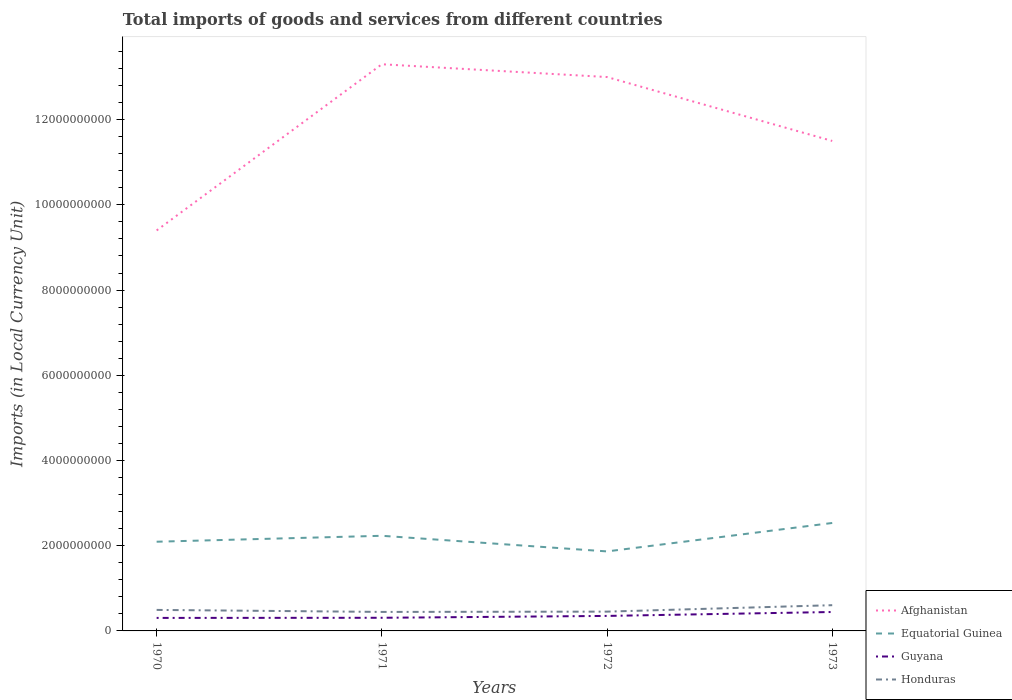How many different coloured lines are there?
Provide a succinct answer. 4. Does the line corresponding to Honduras intersect with the line corresponding to Afghanistan?
Give a very brief answer. No. Is the number of lines equal to the number of legend labels?
Provide a succinct answer. Yes. Across all years, what is the maximum Amount of goods and services imports in Honduras?
Provide a short and direct response. 4.46e+08. In which year was the Amount of goods and services imports in Afghanistan maximum?
Give a very brief answer. 1970. What is the total Amount of goods and services imports in Guyana in the graph?
Your answer should be very brief. -1.39e+08. What is the difference between the highest and the second highest Amount of goods and services imports in Afghanistan?
Provide a succinct answer. 3.90e+09. How many lines are there?
Provide a short and direct response. 4. How many years are there in the graph?
Keep it short and to the point. 4. Does the graph contain any zero values?
Give a very brief answer. No. Does the graph contain grids?
Keep it short and to the point. No. Where does the legend appear in the graph?
Your response must be concise. Bottom right. How many legend labels are there?
Ensure brevity in your answer.  4. How are the legend labels stacked?
Your answer should be very brief. Vertical. What is the title of the graph?
Your answer should be very brief. Total imports of goods and services from different countries. Does "Somalia" appear as one of the legend labels in the graph?
Provide a short and direct response. No. What is the label or title of the X-axis?
Provide a short and direct response. Years. What is the label or title of the Y-axis?
Provide a short and direct response. Imports (in Local Currency Unit). What is the Imports (in Local Currency Unit) of Afghanistan in 1970?
Make the answer very short. 9.40e+09. What is the Imports (in Local Currency Unit) of Equatorial Guinea in 1970?
Make the answer very short. 2.09e+09. What is the Imports (in Local Currency Unit) of Guyana in 1970?
Provide a succinct answer. 3.05e+08. What is the Imports (in Local Currency Unit) in Honduras in 1970?
Offer a terse response. 4.93e+08. What is the Imports (in Local Currency Unit) of Afghanistan in 1971?
Your answer should be compact. 1.33e+1. What is the Imports (in Local Currency Unit) in Equatorial Guinea in 1971?
Provide a succinct answer. 2.23e+09. What is the Imports (in Local Currency Unit) in Guyana in 1971?
Make the answer very short. 3.08e+08. What is the Imports (in Local Currency Unit) in Honduras in 1971?
Give a very brief answer. 4.46e+08. What is the Imports (in Local Currency Unit) of Afghanistan in 1972?
Your answer should be compact. 1.30e+1. What is the Imports (in Local Currency Unit) of Equatorial Guinea in 1972?
Provide a short and direct response. 1.87e+09. What is the Imports (in Local Currency Unit) in Guyana in 1972?
Ensure brevity in your answer.  3.52e+08. What is the Imports (in Local Currency Unit) of Honduras in 1972?
Offer a terse response. 4.53e+08. What is the Imports (in Local Currency Unit) of Afghanistan in 1973?
Your response must be concise. 1.15e+1. What is the Imports (in Local Currency Unit) in Equatorial Guinea in 1973?
Keep it short and to the point. 2.53e+09. What is the Imports (in Local Currency Unit) in Guyana in 1973?
Give a very brief answer. 4.44e+08. What is the Imports (in Local Currency Unit) in Honduras in 1973?
Give a very brief answer. 6.04e+08. Across all years, what is the maximum Imports (in Local Currency Unit) of Afghanistan?
Your answer should be very brief. 1.33e+1. Across all years, what is the maximum Imports (in Local Currency Unit) in Equatorial Guinea?
Provide a short and direct response. 2.53e+09. Across all years, what is the maximum Imports (in Local Currency Unit) of Guyana?
Offer a very short reply. 4.44e+08. Across all years, what is the maximum Imports (in Local Currency Unit) of Honduras?
Keep it short and to the point. 6.04e+08. Across all years, what is the minimum Imports (in Local Currency Unit) in Afghanistan?
Your answer should be compact. 9.40e+09. Across all years, what is the minimum Imports (in Local Currency Unit) of Equatorial Guinea?
Give a very brief answer. 1.87e+09. Across all years, what is the minimum Imports (in Local Currency Unit) of Guyana?
Ensure brevity in your answer.  3.05e+08. Across all years, what is the minimum Imports (in Local Currency Unit) in Honduras?
Make the answer very short. 4.46e+08. What is the total Imports (in Local Currency Unit) in Afghanistan in the graph?
Provide a short and direct response. 4.72e+1. What is the total Imports (in Local Currency Unit) in Equatorial Guinea in the graph?
Make the answer very short. 8.73e+09. What is the total Imports (in Local Currency Unit) in Guyana in the graph?
Offer a terse response. 1.41e+09. What is the total Imports (in Local Currency Unit) of Honduras in the graph?
Your answer should be very brief. 2.00e+09. What is the difference between the Imports (in Local Currency Unit) in Afghanistan in 1970 and that in 1971?
Provide a short and direct response. -3.90e+09. What is the difference between the Imports (in Local Currency Unit) of Equatorial Guinea in 1970 and that in 1971?
Provide a short and direct response. -1.39e+08. What is the difference between the Imports (in Local Currency Unit) of Guyana in 1970 and that in 1971?
Ensure brevity in your answer.  -3.20e+06. What is the difference between the Imports (in Local Currency Unit) of Honduras in 1970 and that in 1971?
Provide a short and direct response. 4.72e+07. What is the difference between the Imports (in Local Currency Unit) in Afghanistan in 1970 and that in 1972?
Give a very brief answer. -3.60e+09. What is the difference between the Imports (in Local Currency Unit) of Equatorial Guinea in 1970 and that in 1972?
Offer a terse response. 2.28e+08. What is the difference between the Imports (in Local Currency Unit) of Guyana in 1970 and that in 1972?
Give a very brief answer. -4.69e+07. What is the difference between the Imports (in Local Currency Unit) in Honduras in 1970 and that in 1972?
Your answer should be very brief. 4.02e+07. What is the difference between the Imports (in Local Currency Unit) of Afghanistan in 1970 and that in 1973?
Your answer should be very brief. -2.10e+09. What is the difference between the Imports (in Local Currency Unit) in Equatorial Guinea in 1970 and that in 1973?
Your answer should be very brief. -4.40e+08. What is the difference between the Imports (in Local Currency Unit) of Guyana in 1970 and that in 1973?
Offer a very short reply. -1.39e+08. What is the difference between the Imports (in Local Currency Unit) in Honduras in 1970 and that in 1973?
Your answer should be very brief. -1.11e+08. What is the difference between the Imports (in Local Currency Unit) in Afghanistan in 1971 and that in 1972?
Provide a succinct answer. 3.00e+08. What is the difference between the Imports (in Local Currency Unit) of Equatorial Guinea in 1971 and that in 1972?
Provide a short and direct response. 3.67e+08. What is the difference between the Imports (in Local Currency Unit) of Guyana in 1971 and that in 1972?
Your response must be concise. -4.37e+07. What is the difference between the Imports (in Local Currency Unit) of Honduras in 1971 and that in 1972?
Provide a succinct answer. -7.00e+06. What is the difference between the Imports (in Local Currency Unit) in Afghanistan in 1971 and that in 1973?
Provide a succinct answer. 1.80e+09. What is the difference between the Imports (in Local Currency Unit) of Equatorial Guinea in 1971 and that in 1973?
Your response must be concise. -3.00e+08. What is the difference between the Imports (in Local Currency Unit) of Guyana in 1971 and that in 1973?
Your answer should be compact. -1.36e+08. What is the difference between the Imports (in Local Currency Unit) of Honduras in 1971 and that in 1973?
Offer a terse response. -1.58e+08. What is the difference between the Imports (in Local Currency Unit) in Afghanistan in 1972 and that in 1973?
Your answer should be compact. 1.50e+09. What is the difference between the Imports (in Local Currency Unit) of Equatorial Guinea in 1972 and that in 1973?
Provide a succinct answer. -6.67e+08. What is the difference between the Imports (in Local Currency Unit) of Guyana in 1972 and that in 1973?
Your response must be concise. -9.20e+07. What is the difference between the Imports (in Local Currency Unit) in Honduras in 1972 and that in 1973?
Your answer should be compact. -1.51e+08. What is the difference between the Imports (in Local Currency Unit) of Afghanistan in 1970 and the Imports (in Local Currency Unit) of Equatorial Guinea in 1971?
Give a very brief answer. 7.17e+09. What is the difference between the Imports (in Local Currency Unit) in Afghanistan in 1970 and the Imports (in Local Currency Unit) in Guyana in 1971?
Your answer should be compact. 9.09e+09. What is the difference between the Imports (in Local Currency Unit) in Afghanistan in 1970 and the Imports (in Local Currency Unit) in Honduras in 1971?
Provide a succinct answer. 8.95e+09. What is the difference between the Imports (in Local Currency Unit) of Equatorial Guinea in 1970 and the Imports (in Local Currency Unit) of Guyana in 1971?
Give a very brief answer. 1.79e+09. What is the difference between the Imports (in Local Currency Unit) in Equatorial Guinea in 1970 and the Imports (in Local Currency Unit) in Honduras in 1971?
Your response must be concise. 1.65e+09. What is the difference between the Imports (in Local Currency Unit) of Guyana in 1970 and the Imports (in Local Currency Unit) of Honduras in 1971?
Offer a very short reply. -1.41e+08. What is the difference between the Imports (in Local Currency Unit) in Afghanistan in 1970 and the Imports (in Local Currency Unit) in Equatorial Guinea in 1972?
Your answer should be compact. 7.53e+09. What is the difference between the Imports (in Local Currency Unit) in Afghanistan in 1970 and the Imports (in Local Currency Unit) in Guyana in 1972?
Offer a terse response. 9.05e+09. What is the difference between the Imports (in Local Currency Unit) of Afghanistan in 1970 and the Imports (in Local Currency Unit) of Honduras in 1972?
Keep it short and to the point. 8.95e+09. What is the difference between the Imports (in Local Currency Unit) of Equatorial Guinea in 1970 and the Imports (in Local Currency Unit) of Guyana in 1972?
Your answer should be very brief. 1.74e+09. What is the difference between the Imports (in Local Currency Unit) of Equatorial Guinea in 1970 and the Imports (in Local Currency Unit) of Honduras in 1972?
Your response must be concise. 1.64e+09. What is the difference between the Imports (in Local Currency Unit) in Guyana in 1970 and the Imports (in Local Currency Unit) in Honduras in 1972?
Make the answer very short. -1.48e+08. What is the difference between the Imports (in Local Currency Unit) in Afghanistan in 1970 and the Imports (in Local Currency Unit) in Equatorial Guinea in 1973?
Keep it short and to the point. 6.87e+09. What is the difference between the Imports (in Local Currency Unit) in Afghanistan in 1970 and the Imports (in Local Currency Unit) in Guyana in 1973?
Your answer should be very brief. 8.96e+09. What is the difference between the Imports (in Local Currency Unit) of Afghanistan in 1970 and the Imports (in Local Currency Unit) of Honduras in 1973?
Your response must be concise. 8.80e+09. What is the difference between the Imports (in Local Currency Unit) in Equatorial Guinea in 1970 and the Imports (in Local Currency Unit) in Guyana in 1973?
Provide a succinct answer. 1.65e+09. What is the difference between the Imports (in Local Currency Unit) in Equatorial Guinea in 1970 and the Imports (in Local Currency Unit) in Honduras in 1973?
Provide a short and direct response. 1.49e+09. What is the difference between the Imports (in Local Currency Unit) in Guyana in 1970 and the Imports (in Local Currency Unit) in Honduras in 1973?
Offer a terse response. -2.99e+08. What is the difference between the Imports (in Local Currency Unit) in Afghanistan in 1971 and the Imports (in Local Currency Unit) in Equatorial Guinea in 1972?
Provide a short and direct response. 1.14e+1. What is the difference between the Imports (in Local Currency Unit) of Afghanistan in 1971 and the Imports (in Local Currency Unit) of Guyana in 1972?
Your response must be concise. 1.29e+1. What is the difference between the Imports (in Local Currency Unit) of Afghanistan in 1971 and the Imports (in Local Currency Unit) of Honduras in 1972?
Your answer should be very brief. 1.28e+1. What is the difference between the Imports (in Local Currency Unit) in Equatorial Guinea in 1971 and the Imports (in Local Currency Unit) in Guyana in 1972?
Your answer should be very brief. 1.88e+09. What is the difference between the Imports (in Local Currency Unit) in Equatorial Guinea in 1971 and the Imports (in Local Currency Unit) in Honduras in 1972?
Your response must be concise. 1.78e+09. What is the difference between the Imports (in Local Currency Unit) of Guyana in 1971 and the Imports (in Local Currency Unit) of Honduras in 1972?
Your response must be concise. -1.44e+08. What is the difference between the Imports (in Local Currency Unit) of Afghanistan in 1971 and the Imports (in Local Currency Unit) of Equatorial Guinea in 1973?
Make the answer very short. 1.08e+1. What is the difference between the Imports (in Local Currency Unit) of Afghanistan in 1971 and the Imports (in Local Currency Unit) of Guyana in 1973?
Provide a short and direct response. 1.29e+1. What is the difference between the Imports (in Local Currency Unit) in Afghanistan in 1971 and the Imports (in Local Currency Unit) in Honduras in 1973?
Your answer should be compact. 1.27e+1. What is the difference between the Imports (in Local Currency Unit) in Equatorial Guinea in 1971 and the Imports (in Local Currency Unit) in Guyana in 1973?
Your answer should be very brief. 1.79e+09. What is the difference between the Imports (in Local Currency Unit) in Equatorial Guinea in 1971 and the Imports (in Local Currency Unit) in Honduras in 1973?
Offer a terse response. 1.63e+09. What is the difference between the Imports (in Local Currency Unit) in Guyana in 1971 and the Imports (in Local Currency Unit) in Honduras in 1973?
Provide a short and direct response. -2.96e+08. What is the difference between the Imports (in Local Currency Unit) of Afghanistan in 1972 and the Imports (in Local Currency Unit) of Equatorial Guinea in 1973?
Offer a terse response. 1.05e+1. What is the difference between the Imports (in Local Currency Unit) of Afghanistan in 1972 and the Imports (in Local Currency Unit) of Guyana in 1973?
Make the answer very short. 1.26e+1. What is the difference between the Imports (in Local Currency Unit) of Afghanistan in 1972 and the Imports (in Local Currency Unit) of Honduras in 1973?
Provide a succinct answer. 1.24e+1. What is the difference between the Imports (in Local Currency Unit) of Equatorial Guinea in 1972 and the Imports (in Local Currency Unit) of Guyana in 1973?
Keep it short and to the point. 1.42e+09. What is the difference between the Imports (in Local Currency Unit) of Equatorial Guinea in 1972 and the Imports (in Local Currency Unit) of Honduras in 1973?
Provide a short and direct response. 1.26e+09. What is the difference between the Imports (in Local Currency Unit) of Guyana in 1972 and the Imports (in Local Currency Unit) of Honduras in 1973?
Your answer should be very brief. -2.52e+08. What is the average Imports (in Local Currency Unit) in Afghanistan per year?
Your response must be concise. 1.18e+1. What is the average Imports (in Local Currency Unit) of Equatorial Guinea per year?
Offer a terse response. 2.18e+09. What is the average Imports (in Local Currency Unit) of Guyana per year?
Offer a very short reply. 3.53e+08. What is the average Imports (in Local Currency Unit) of Honduras per year?
Offer a terse response. 4.99e+08. In the year 1970, what is the difference between the Imports (in Local Currency Unit) in Afghanistan and Imports (in Local Currency Unit) in Equatorial Guinea?
Keep it short and to the point. 7.31e+09. In the year 1970, what is the difference between the Imports (in Local Currency Unit) of Afghanistan and Imports (in Local Currency Unit) of Guyana?
Offer a very short reply. 9.09e+09. In the year 1970, what is the difference between the Imports (in Local Currency Unit) of Afghanistan and Imports (in Local Currency Unit) of Honduras?
Your answer should be compact. 8.91e+09. In the year 1970, what is the difference between the Imports (in Local Currency Unit) in Equatorial Guinea and Imports (in Local Currency Unit) in Guyana?
Ensure brevity in your answer.  1.79e+09. In the year 1970, what is the difference between the Imports (in Local Currency Unit) of Equatorial Guinea and Imports (in Local Currency Unit) of Honduras?
Make the answer very short. 1.60e+09. In the year 1970, what is the difference between the Imports (in Local Currency Unit) in Guyana and Imports (in Local Currency Unit) in Honduras?
Your answer should be compact. -1.88e+08. In the year 1971, what is the difference between the Imports (in Local Currency Unit) in Afghanistan and Imports (in Local Currency Unit) in Equatorial Guinea?
Your response must be concise. 1.11e+1. In the year 1971, what is the difference between the Imports (in Local Currency Unit) in Afghanistan and Imports (in Local Currency Unit) in Guyana?
Ensure brevity in your answer.  1.30e+1. In the year 1971, what is the difference between the Imports (in Local Currency Unit) in Afghanistan and Imports (in Local Currency Unit) in Honduras?
Your response must be concise. 1.29e+1. In the year 1971, what is the difference between the Imports (in Local Currency Unit) in Equatorial Guinea and Imports (in Local Currency Unit) in Guyana?
Make the answer very short. 1.92e+09. In the year 1971, what is the difference between the Imports (in Local Currency Unit) in Equatorial Guinea and Imports (in Local Currency Unit) in Honduras?
Your response must be concise. 1.79e+09. In the year 1971, what is the difference between the Imports (in Local Currency Unit) of Guyana and Imports (in Local Currency Unit) of Honduras?
Provide a short and direct response. -1.38e+08. In the year 1972, what is the difference between the Imports (in Local Currency Unit) of Afghanistan and Imports (in Local Currency Unit) of Equatorial Guinea?
Keep it short and to the point. 1.11e+1. In the year 1972, what is the difference between the Imports (in Local Currency Unit) in Afghanistan and Imports (in Local Currency Unit) in Guyana?
Your response must be concise. 1.26e+1. In the year 1972, what is the difference between the Imports (in Local Currency Unit) in Afghanistan and Imports (in Local Currency Unit) in Honduras?
Keep it short and to the point. 1.25e+1. In the year 1972, what is the difference between the Imports (in Local Currency Unit) in Equatorial Guinea and Imports (in Local Currency Unit) in Guyana?
Ensure brevity in your answer.  1.51e+09. In the year 1972, what is the difference between the Imports (in Local Currency Unit) of Equatorial Guinea and Imports (in Local Currency Unit) of Honduras?
Ensure brevity in your answer.  1.41e+09. In the year 1972, what is the difference between the Imports (in Local Currency Unit) of Guyana and Imports (in Local Currency Unit) of Honduras?
Your response must be concise. -1.01e+08. In the year 1973, what is the difference between the Imports (in Local Currency Unit) of Afghanistan and Imports (in Local Currency Unit) of Equatorial Guinea?
Your response must be concise. 8.97e+09. In the year 1973, what is the difference between the Imports (in Local Currency Unit) in Afghanistan and Imports (in Local Currency Unit) in Guyana?
Make the answer very short. 1.11e+1. In the year 1973, what is the difference between the Imports (in Local Currency Unit) of Afghanistan and Imports (in Local Currency Unit) of Honduras?
Offer a terse response. 1.09e+1. In the year 1973, what is the difference between the Imports (in Local Currency Unit) in Equatorial Guinea and Imports (in Local Currency Unit) in Guyana?
Your answer should be compact. 2.09e+09. In the year 1973, what is the difference between the Imports (in Local Currency Unit) in Equatorial Guinea and Imports (in Local Currency Unit) in Honduras?
Your answer should be compact. 1.93e+09. In the year 1973, what is the difference between the Imports (in Local Currency Unit) of Guyana and Imports (in Local Currency Unit) of Honduras?
Your response must be concise. -1.60e+08. What is the ratio of the Imports (in Local Currency Unit) of Afghanistan in 1970 to that in 1971?
Your response must be concise. 0.71. What is the ratio of the Imports (in Local Currency Unit) of Equatorial Guinea in 1970 to that in 1971?
Offer a very short reply. 0.94. What is the ratio of the Imports (in Local Currency Unit) of Honduras in 1970 to that in 1971?
Make the answer very short. 1.11. What is the ratio of the Imports (in Local Currency Unit) of Afghanistan in 1970 to that in 1972?
Your answer should be very brief. 0.72. What is the ratio of the Imports (in Local Currency Unit) in Equatorial Guinea in 1970 to that in 1972?
Offer a very short reply. 1.12. What is the ratio of the Imports (in Local Currency Unit) of Guyana in 1970 to that in 1972?
Your response must be concise. 0.87. What is the ratio of the Imports (in Local Currency Unit) in Honduras in 1970 to that in 1972?
Make the answer very short. 1.09. What is the ratio of the Imports (in Local Currency Unit) of Afghanistan in 1970 to that in 1973?
Make the answer very short. 0.82. What is the ratio of the Imports (in Local Currency Unit) of Equatorial Guinea in 1970 to that in 1973?
Offer a terse response. 0.83. What is the ratio of the Imports (in Local Currency Unit) of Guyana in 1970 to that in 1973?
Your answer should be compact. 0.69. What is the ratio of the Imports (in Local Currency Unit) in Honduras in 1970 to that in 1973?
Your response must be concise. 0.82. What is the ratio of the Imports (in Local Currency Unit) in Afghanistan in 1971 to that in 1972?
Your answer should be very brief. 1.02. What is the ratio of the Imports (in Local Currency Unit) in Equatorial Guinea in 1971 to that in 1972?
Make the answer very short. 1.2. What is the ratio of the Imports (in Local Currency Unit) in Guyana in 1971 to that in 1972?
Make the answer very short. 0.88. What is the ratio of the Imports (in Local Currency Unit) in Honduras in 1971 to that in 1972?
Give a very brief answer. 0.98. What is the ratio of the Imports (in Local Currency Unit) of Afghanistan in 1971 to that in 1973?
Your answer should be very brief. 1.16. What is the ratio of the Imports (in Local Currency Unit) of Equatorial Guinea in 1971 to that in 1973?
Your answer should be very brief. 0.88. What is the ratio of the Imports (in Local Currency Unit) of Guyana in 1971 to that in 1973?
Your response must be concise. 0.69. What is the ratio of the Imports (in Local Currency Unit) in Honduras in 1971 to that in 1973?
Offer a very short reply. 0.74. What is the ratio of the Imports (in Local Currency Unit) in Afghanistan in 1972 to that in 1973?
Offer a very short reply. 1.13. What is the ratio of the Imports (in Local Currency Unit) in Equatorial Guinea in 1972 to that in 1973?
Your response must be concise. 0.74. What is the ratio of the Imports (in Local Currency Unit) in Guyana in 1972 to that in 1973?
Offer a terse response. 0.79. What is the difference between the highest and the second highest Imports (in Local Currency Unit) in Afghanistan?
Give a very brief answer. 3.00e+08. What is the difference between the highest and the second highest Imports (in Local Currency Unit) in Equatorial Guinea?
Provide a short and direct response. 3.00e+08. What is the difference between the highest and the second highest Imports (in Local Currency Unit) in Guyana?
Ensure brevity in your answer.  9.20e+07. What is the difference between the highest and the second highest Imports (in Local Currency Unit) in Honduras?
Your answer should be compact. 1.11e+08. What is the difference between the highest and the lowest Imports (in Local Currency Unit) of Afghanistan?
Provide a succinct answer. 3.90e+09. What is the difference between the highest and the lowest Imports (in Local Currency Unit) in Equatorial Guinea?
Make the answer very short. 6.67e+08. What is the difference between the highest and the lowest Imports (in Local Currency Unit) in Guyana?
Provide a short and direct response. 1.39e+08. What is the difference between the highest and the lowest Imports (in Local Currency Unit) of Honduras?
Keep it short and to the point. 1.58e+08. 